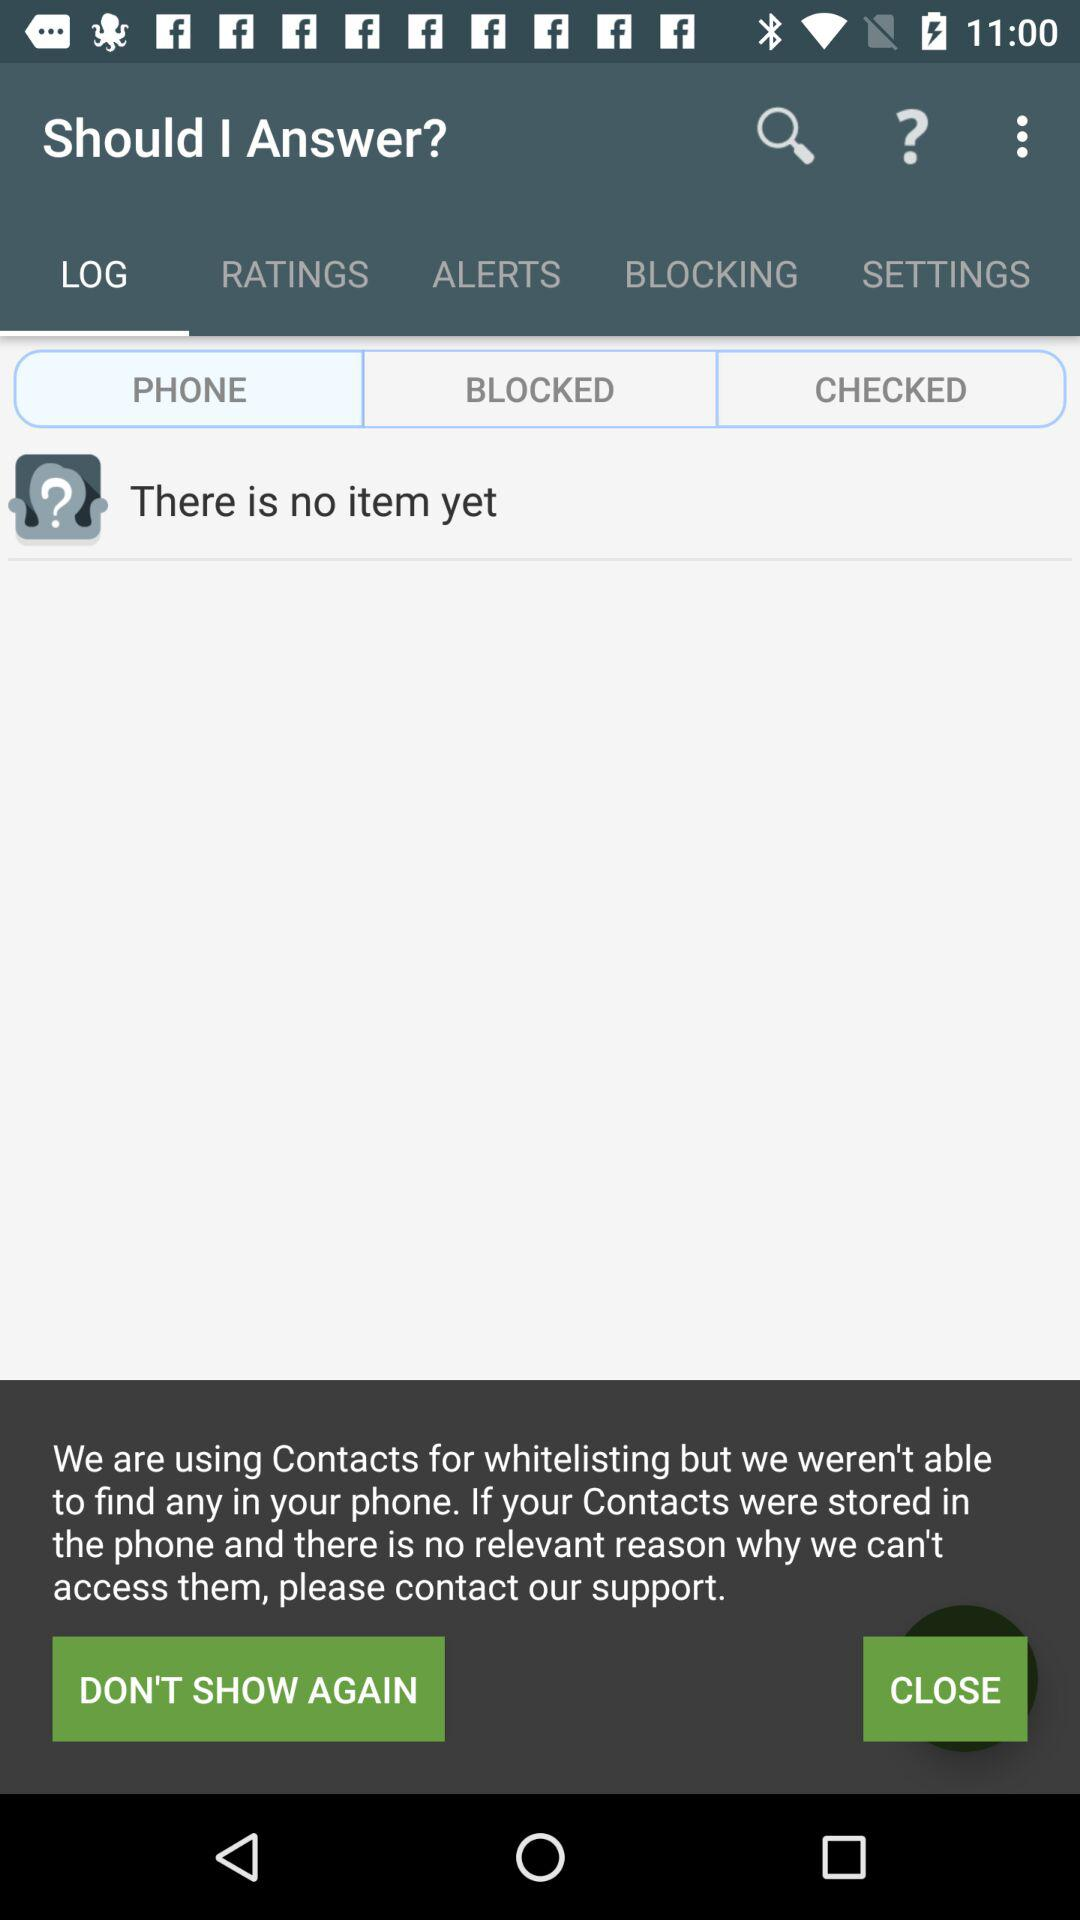How many items are there right now? There are no items right now. 